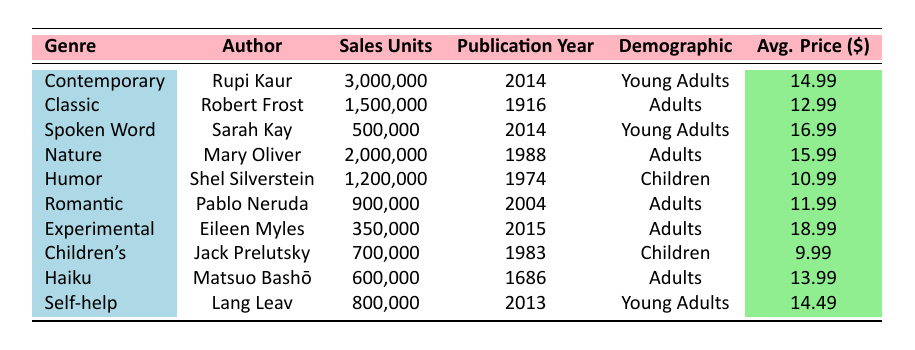What is the average sales unit for the genre "Children's"? There is one entry for the genre "Children's" with sales units of 700,000. Since there is only one value, the average is simply equal to that value.
Answer: 700,000 Which author has the highest sales units? Rupi Kaur has the highest sales units at 3,000,000. This is the maximum value in the "Sales Units" column.
Answer: Rupi Kaur What is the total sales units for all genres targeting "Young Adults"? The sales units for "Young Adults" are from Rupi Kaur (3,000,000), Sarah Kay (500,000), and Lang Leav (800,000). Summing these gives 3,000,000 + 500,000 + 800,000 = 4,300,000.
Answer: 4,300,000 Is there a genre that has sales units greater than 1 million and is targeted at "Adults"? The genres "Classic" (1,500,000) and "Nature" (2,000,000) both have sales units greater than 1 million, indicating there are genres that satisfy these criteria.
Answer: Yes What is the average price of poetry books sold to "Children"? The "Children's" genre has one entry which is "Humor" ($10.99), and "Children's" (Jack Prelutsky) at $9.99. The average price is (10.99 + 9.99) / 2 = 10.49 since there are two entries.
Answer: 10.49 Who published the earliest poetry book listed in the table? The earliest publication year is 1686 attributed to Matsuo Bashō in the "Haiku" genre. It is the oldest year in the "Publication Year" column.
Answer: Matsuo Bashō What is the difference in sales units between the "Contemporary" and "Romantic" genres? For "Contemporary," the sales units are 3,000,000, and for "Romantic," they are 900,000. The difference is 3,000,000 - 900,000 = 2,100,000.
Answer: 2,100,000 Are there more sales units for "Spoken Word" than "Experimental"? "Spoken Word" has 500,000 sales units while "Experimental" has 350,000. Since 500,000 is greater than 350,000, the statement is true.
Answer: Yes What is the average publication year for all the poetry books listed? To find the average, sum the publication years: 2014 + 1916 + 2014 + 1988 + 1974 + 2004 + 2015 + 1983 + 1686 + 2013 = 20000. Divide by the total number of books (10), giving an average of 20000 / 10 = 2000.
Answer: 2000 Which demographic has the highest average price for poetry books? The average price for "Young Adults" (14.99 + 16.99 + 14.49) is (14.99 + 16.99 + 14.49) / 3 = 15.16. For "Adults" (12.99 + 15.99 + 11.99 + 18.99) is (12.99 + 15.99 + 11.99 + 18.99) / 4 = 14.99. For "Children" it is (10.99 + 9.99) / 2 = 10.49. Comparing these, "Young Adults" has the highest average price.
Answer: Young Adults 